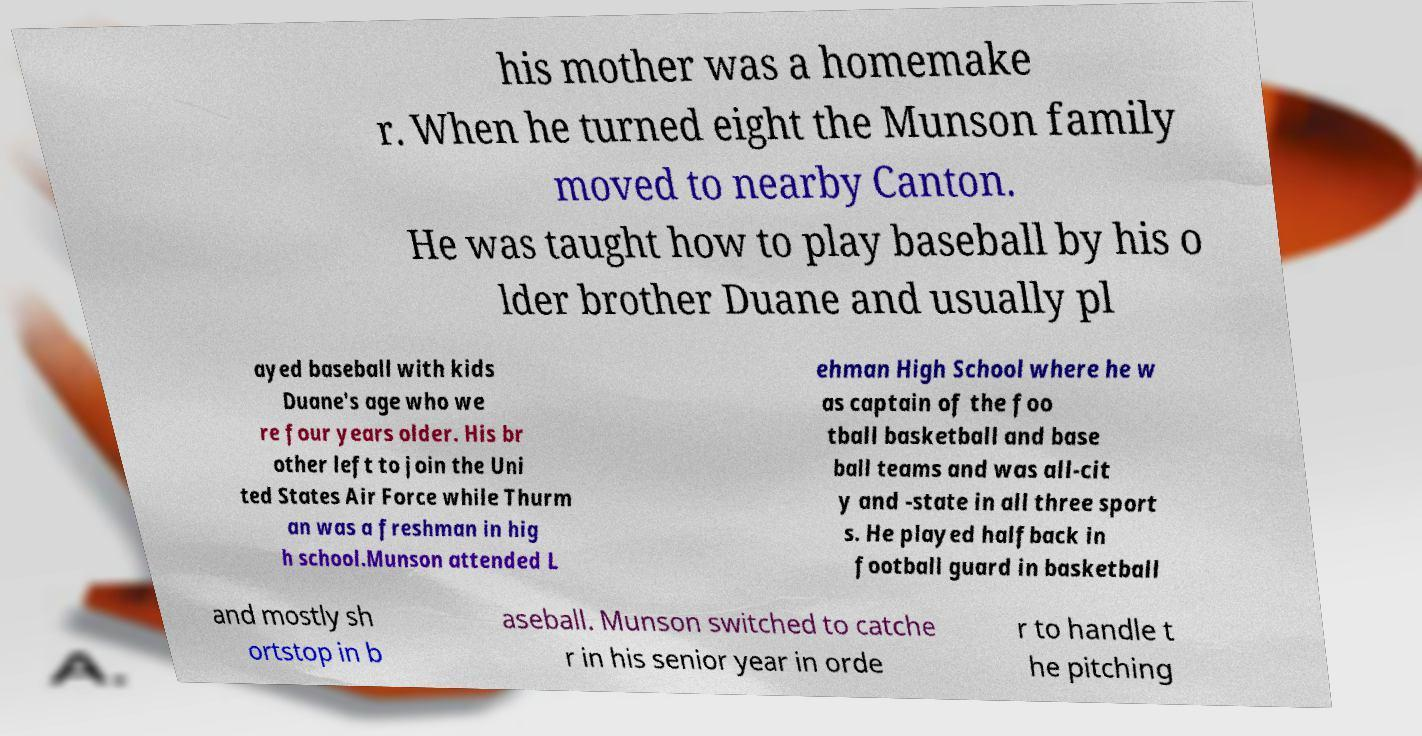Please read and relay the text visible in this image. What does it say? his mother was a homemake r. When he turned eight the Munson family moved to nearby Canton. He was taught how to play baseball by his o lder brother Duane and usually pl ayed baseball with kids Duane's age who we re four years older. His br other left to join the Uni ted States Air Force while Thurm an was a freshman in hig h school.Munson attended L ehman High School where he w as captain of the foo tball basketball and base ball teams and was all-cit y and -state in all three sport s. He played halfback in football guard in basketball and mostly sh ortstop in b aseball. Munson switched to catche r in his senior year in orde r to handle t he pitching 